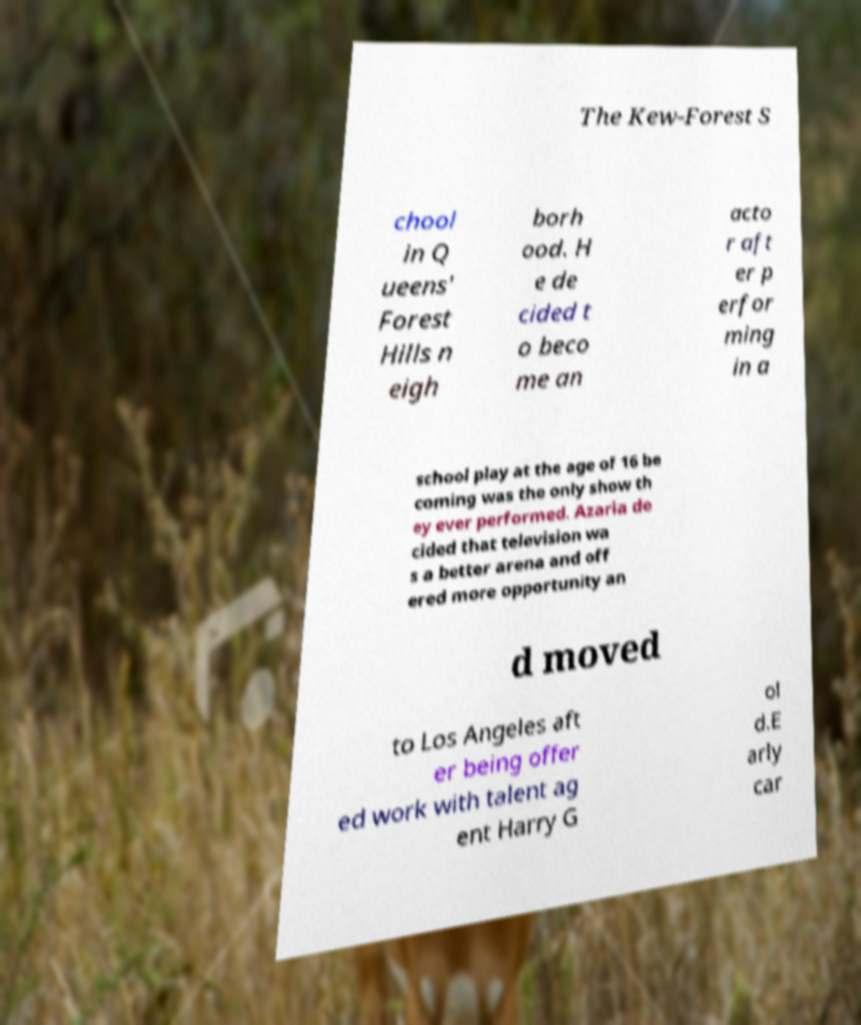Can you read and provide the text displayed in the image?This photo seems to have some interesting text. Can you extract and type it out for me? The Kew-Forest S chool in Q ueens' Forest Hills n eigh borh ood. H e de cided t o beco me an acto r aft er p erfor ming in a school play at the age of 16 be coming was the only show th ey ever performed. Azaria de cided that television wa s a better arena and off ered more opportunity an d moved to Los Angeles aft er being offer ed work with talent ag ent Harry G ol d.E arly car 